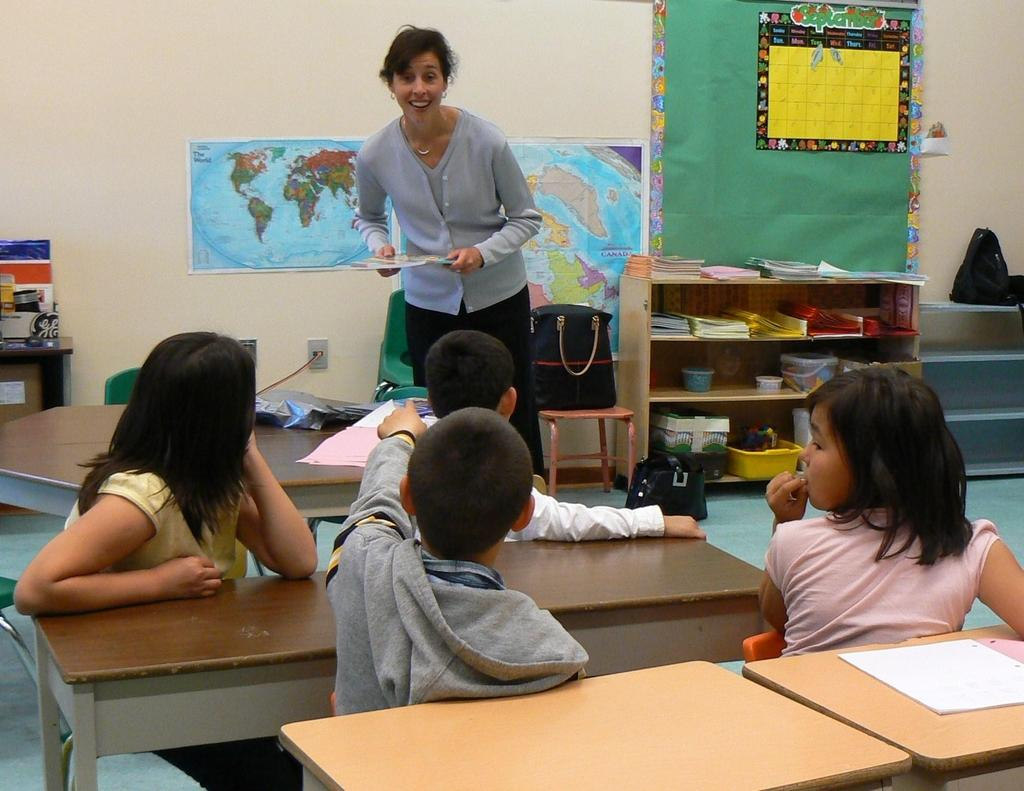What can be seen in the image involving multiple individuals? There is a group of children in the image. How are the children positioned in relation to the chairs? The children are sitting on chairs. What is located behind the chairs? The chairs are in front of a table. Who else is present in the image besides the children? There is a woman in the image. What is the woman's position in relation to the children? The woman is standing on the floor. What type of brick is being used to build the cake in the image? There is no brick or cake present in the image; it features a group of children sitting on chairs in front of a table, with a woman standing nearby. 